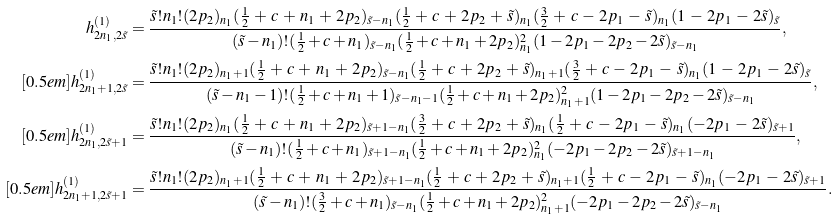Convert formula to latex. <formula><loc_0><loc_0><loc_500><loc_500>h _ { 2 n _ { 1 } , 2 \tilde { s } } ^ { ( 1 ) } & = \frac { \tilde { s } ! n _ { 1 } ! ( 2 p _ { 2 } ) _ { n _ { 1 } } ( \frac { 1 } { 2 } \, + \, c \, + \, n _ { 1 } \, + \, 2 p _ { 2 } ) _ { \tilde { s } - n _ { 1 } } ( \frac { 1 } { 2 } \, + \, c \, + \, 2 p _ { 2 } \, + \, \tilde { s } ) _ { n _ { 1 } } ( \frac { 3 } { 2 } \, + \, c \, - \, 2 p _ { 1 } \, - \, \tilde { s } ) _ { n _ { 1 } } ( 1 \, - \, 2 p _ { 1 } \, - \, 2 \tilde { s } ) _ { \tilde { s } } } { ( \tilde { s } - n _ { 1 } ) ! ( \frac { 1 } { 2 } + c + n _ { 1 } ) _ { \tilde { s } - n _ { 1 } } ( \frac { 1 } { 2 } + c + n _ { 1 } + 2 p _ { 2 } ) _ { n _ { 1 } } ^ { 2 } ( 1 - 2 p _ { 1 } - 2 p _ { 2 } - 2 \tilde { s } ) _ { \tilde { s } - n _ { 1 } } } , \\ [ 0 . 5 e m ] h _ { 2 n _ { 1 } + 1 , 2 \tilde { s } } ^ { ( 1 ) } & = \frac { \tilde { s } ! n _ { 1 } ! ( 2 p _ { 2 } ) _ { n _ { 1 } + 1 } ( \frac { 1 } { 2 } \, + \, c \, + \, n _ { 1 } \, + \, 2 p _ { 2 } ) _ { \tilde { s } - n _ { 1 } } ( \frac { 1 } { 2 } \, + \, c \, + \, 2 p _ { 2 } \, + \, \tilde { s } ) _ { n _ { 1 } + 1 } ( \frac { 3 } { 2 } \, + \, c \, - \, 2 p _ { 1 } \, - \, \tilde { s } ) _ { n _ { 1 } } ( 1 \, - \, 2 p _ { 1 } \, - \, 2 \tilde { s } ) _ { \tilde { s } } } { ( \tilde { s } - n _ { 1 } - 1 ) ! ( \frac { 1 } { 2 } + c + n _ { 1 } + 1 ) _ { \tilde { s } - n _ { 1 } - 1 } ( \frac { 1 } { 2 } + c + n _ { 1 } + 2 p _ { 2 } ) _ { n _ { 1 } + 1 } ^ { 2 } ( 1 - 2 p _ { 1 } - 2 p _ { 2 } - 2 \tilde { s } ) _ { \tilde { s } - n _ { 1 } } } , \\ [ 0 . 5 e m ] h _ { 2 n _ { 1 } , 2 \tilde { s } + 1 } ^ { ( 1 ) } & = \frac { \tilde { s } ! n _ { 1 } ! ( 2 p _ { 2 } ) _ { n _ { 1 } } ( \frac { 1 } { 2 } \, + \, c \, + \, n _ { 1 } \, + \, 2 p _ { 2 } ) _ { \tilde { s } + 1 - n _ { 1 } } ( \frac { 3 } { 2 } \, + \, c \, + \, 2 p _ { 2 } \, + \, \tilde { s } ) _ { n _ { 1 } } ( \frac { 1 } { 2 } \, + \, c \, - \, 2 p _ { 1 } \, - \, \tilde { s } ) _ { n _ { 1 } } ( - 2 p _ { 1 } \, - \, 2 \tilde { s } ) _ { \tilde { s } + 1 } } { ( \tilde { s } - n _ { 1 } ) ! ( \frac { 1 } { 2 } + c + n _ { 1 } ) _ { \tilde { s } + 1 - n _ { 1 } } ( \frac { 1 } { 2 } + c + n _ { 1 } + 2 p _ { 2 } ) _ { n _ { 1 } } ^ { 2 } ( - 2 p _ { 1 } - 2 p _ { 2 } - 2 \tilde { s } ) _ { \tilde { s } + 1 - n _ { 1 } } } , \\ [ 0 . 5 e m ] h _ { 2 n _ { 1 } + 1 , 2 \tilde { s } + 1 } ^ { ( 1 ) } & = \frac { \tilde { s } ! n _ { 1 } ! ( 2 p _ { 2 } ) _ { n _ { 1 } + 1 } ( \frac { 1 } { 2 } \, + \, c \, + \, n _ { 1 } \, + \, 2 p _ { 2 } ) _ { \tilde { s } + 1 - n _ { 1 } } ( \frac { 1 } { 2 } \, + \, c \, + \, 2 p _ { 2 } \, + \, \tilde { s } ) _ { n _ { 1 } + 1 } ( \frac { 1 } { 2 } \, + \, c \, - \, 2 p _ { 1 } \, - \, \tilde { s } ) _ { n _ { 1 } } ( - 2 p _ { 1 } \, - \, 2 \tilde { s } ) _ { \tilde { s } + 1 } } { ( \tilde { s } - n _ { 1 } ) ! ( \frac { 3 } { 2 } + c + n _ { 1 } ) _ { \tilde { s } - n _ { 1 } } ( \frac { 1 } { 2 } + c + n _ { 1 } + 2 p _ { 2 } ) _ { n _ { 1 } + 1 } ^ { 2 } ( - 2 p _ { 1 } - 2 p _ { 2 } - 2 \tilde { s } ) _ { \tilde { s } - n _ { 1 } } } .</formula> 